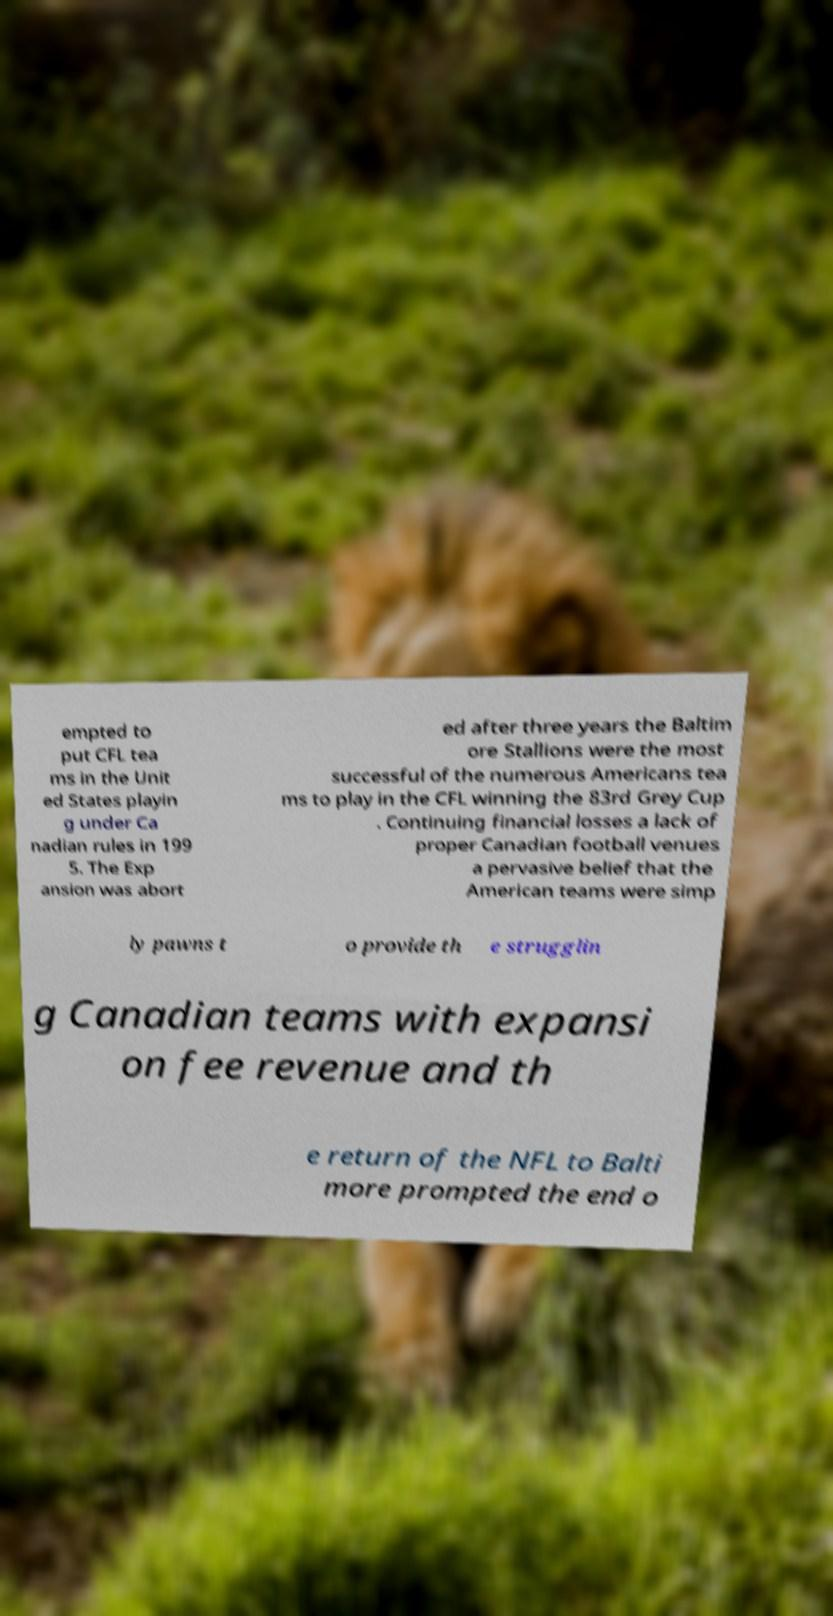Could you assist in decoding the text presented in this image and type it out clearly? empted to put CFL tea ms in the Unit ed States playin g under Ca nadian rules in 199 5. The Exp ansion was abort ed after three years the Baltim ore Stallions were the most successful of the numerous Americans tea ms to play in the CFL winning the 83rd Grey Cup . Continuing financial losses a lack of proper Canadian football venues a pervasive belief that the American teams were simp ly pawns t o provide th e strugglin g Canadian teams with expansi on fee revenue and th e return of the NFL to Balti more prompted the end o 